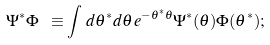<formula> <loc_0><loc_0><loc_500><loc_500>\Psi ^ { * } \Phi \ \equiv \int \, d \theta ^ { * } d \theta \, e ^ { - \theta ^ { * } \theta } \Psi ^ { * } ( \theta ) \Phi ( \theta ^ { * } ) ;</formula> 